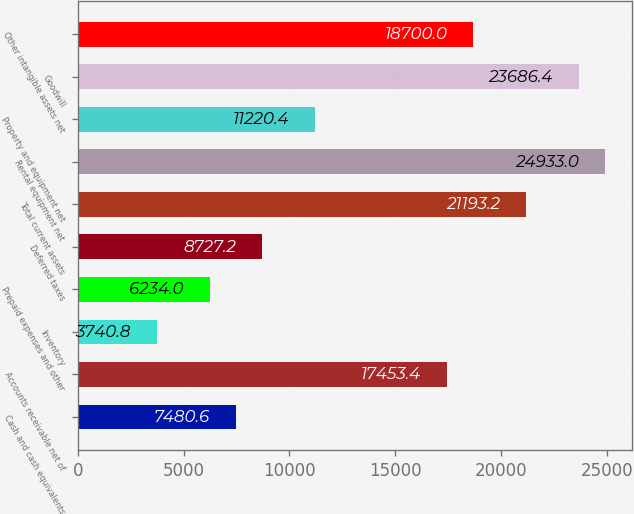Convert chart to OTSL. <chart><loc_0><loc_0><loc_500><loc_500><bar_chart><fcel>Cash and cash equivalents<fcel>Accounts receivable net of<fcel>Inventory<fcel>Prepaid expenses and other<fcel>Deferred taxes<fcel>Total current assets<fcel>Rental equipment net<fcel>Property and equipment net<fcel>Goodwill<fcel>Other intangible assets net<nl><fcel>7480.6<fcel>17453.4<fcel>3740.8<fcel>6234<fcel>8727.2<fcel>21193.2<fcel>24933<fcel>11220.4<fcel>23686.4<fcel>18700<nl></chart> 